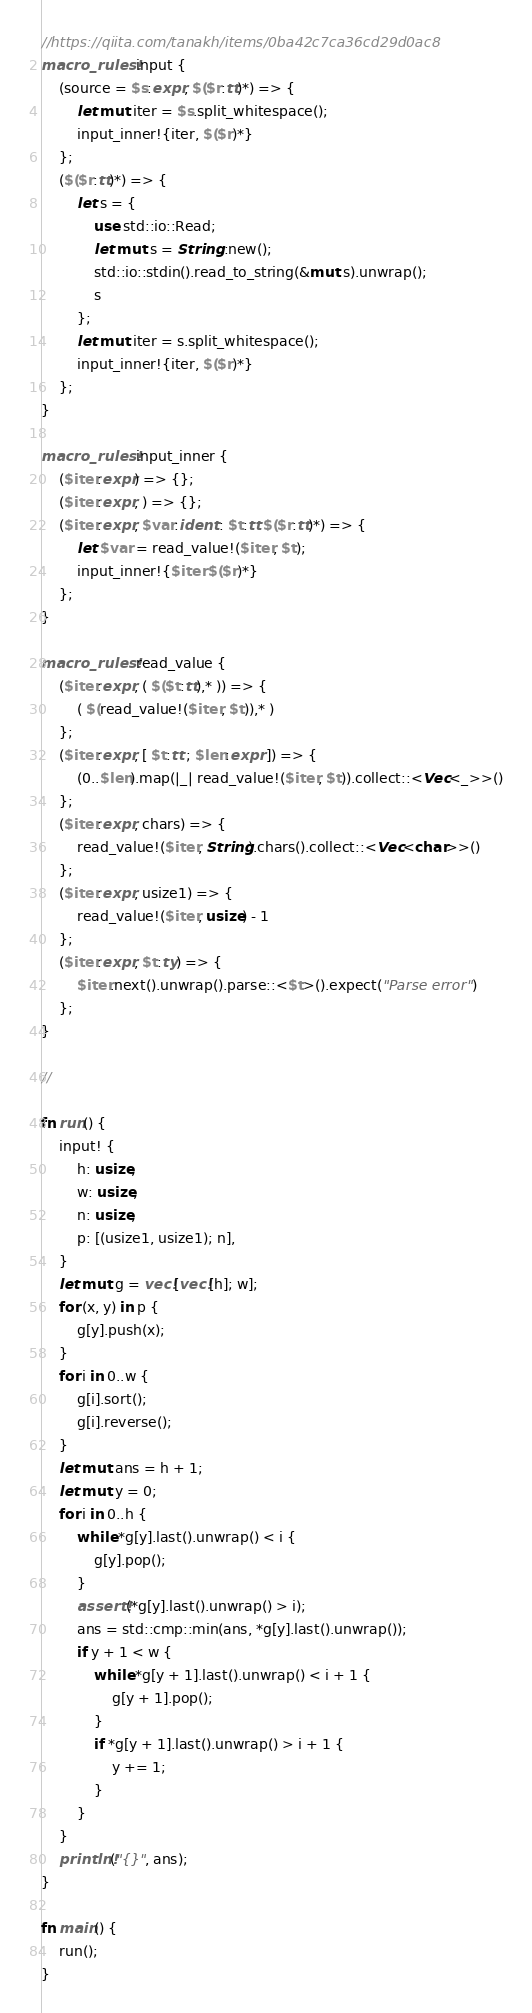Convert code to text. <code><loc_0><loc_0><loc_500><loc_500><_Rust_>//https://qiita.com/tanakh/items/0ba42c7ca36cd29d0ac8
macro_rules! input {
    (source = $s:expr, $($r:tt)*) => {
        let mut iter = $s.split_whitespace();
        input_inner!{iter, $($r)*}
    };
    ($($r:tt)*) => {
        let s = {
            use std::io::Read;
            let mut s = String::new();
            std::io::stdin().read_to_string(&mut s).unwrap();
            s
        };
        let mut iter = s.split_whitespace();
        input_inner!{iter, $($r)*}
    };
}

macro_rules! input_inner {
    ($iter:expr) => {};
    ($iter:expr, ) => {};
    ($iter:expr, $var:ident : $t:tt $($r:tt)*) => {
        let $var = read_value!($iter, $t);
        input_inner!{$iter $($r)*}
    };
}

macro_rules! read_value {
    ($iter:expr, ( $($t:tt),* )) => {
        ( $(read_value!($iter, $t)),* )
    };
    ($iter:expr, [ $t:tt ; $len:expr ]) => {
        (0..$len).map(|_| read_value!($iter, $t)).collect::<Vec<_>>()
    };
    ($iter:expr, chars) => {
        read_value!($iter, String).chars().collect::<Vec<char>>()
    };
    ($iter:expr, usize1) => {
        read_value!($iter, usize) - 1
    };
    ($iter:expr, $t:ty) => {
        $iter.next().unwrap().parse::<$t>().expect("Parse error")
    };
}

//

fn run() {
    input! {
        h: usize,
        w: usize,
        n: usize,
        p: [(usize1, usize1); n],
    }
    let mut g = vec![vec![h]; w];
    for (x, y) in p {
        g[y].push(x);
    }
    for i in 0..w {
        g[i].sort();
        g[i].reverse();
    }
    let mut ans = h + 1;
    let mut y = 0;
    for i in 0..h {
        while *g[y].last().unwrap() < i {
            g[y].pop();
        }
        assert!(*g[y].last().unwrap() > i);
        ans = std::cmp::min(ans, *g[y].last().unwrap());
        if y + 1 < w {
            while *g[y + 1].last().unwrap() < i + 1 {
                g[y + 1].pop();
            }
            if *g[y + 1].last().unwrap() > i + 1 {
                y += 1;
            }
        }
    }
    println!("{}", ans);
}

fn main() {
    run();
}
</code> 